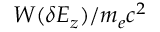Convert formula to latex. <formula><loc_0><loc_0><loc_500><loc_500>W ( \delta E _ { z } ) / m _ { e } c ^ { 2 }</formula> 